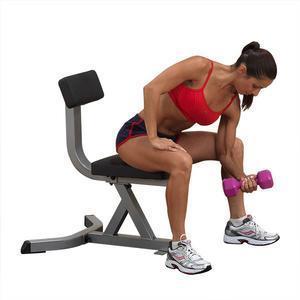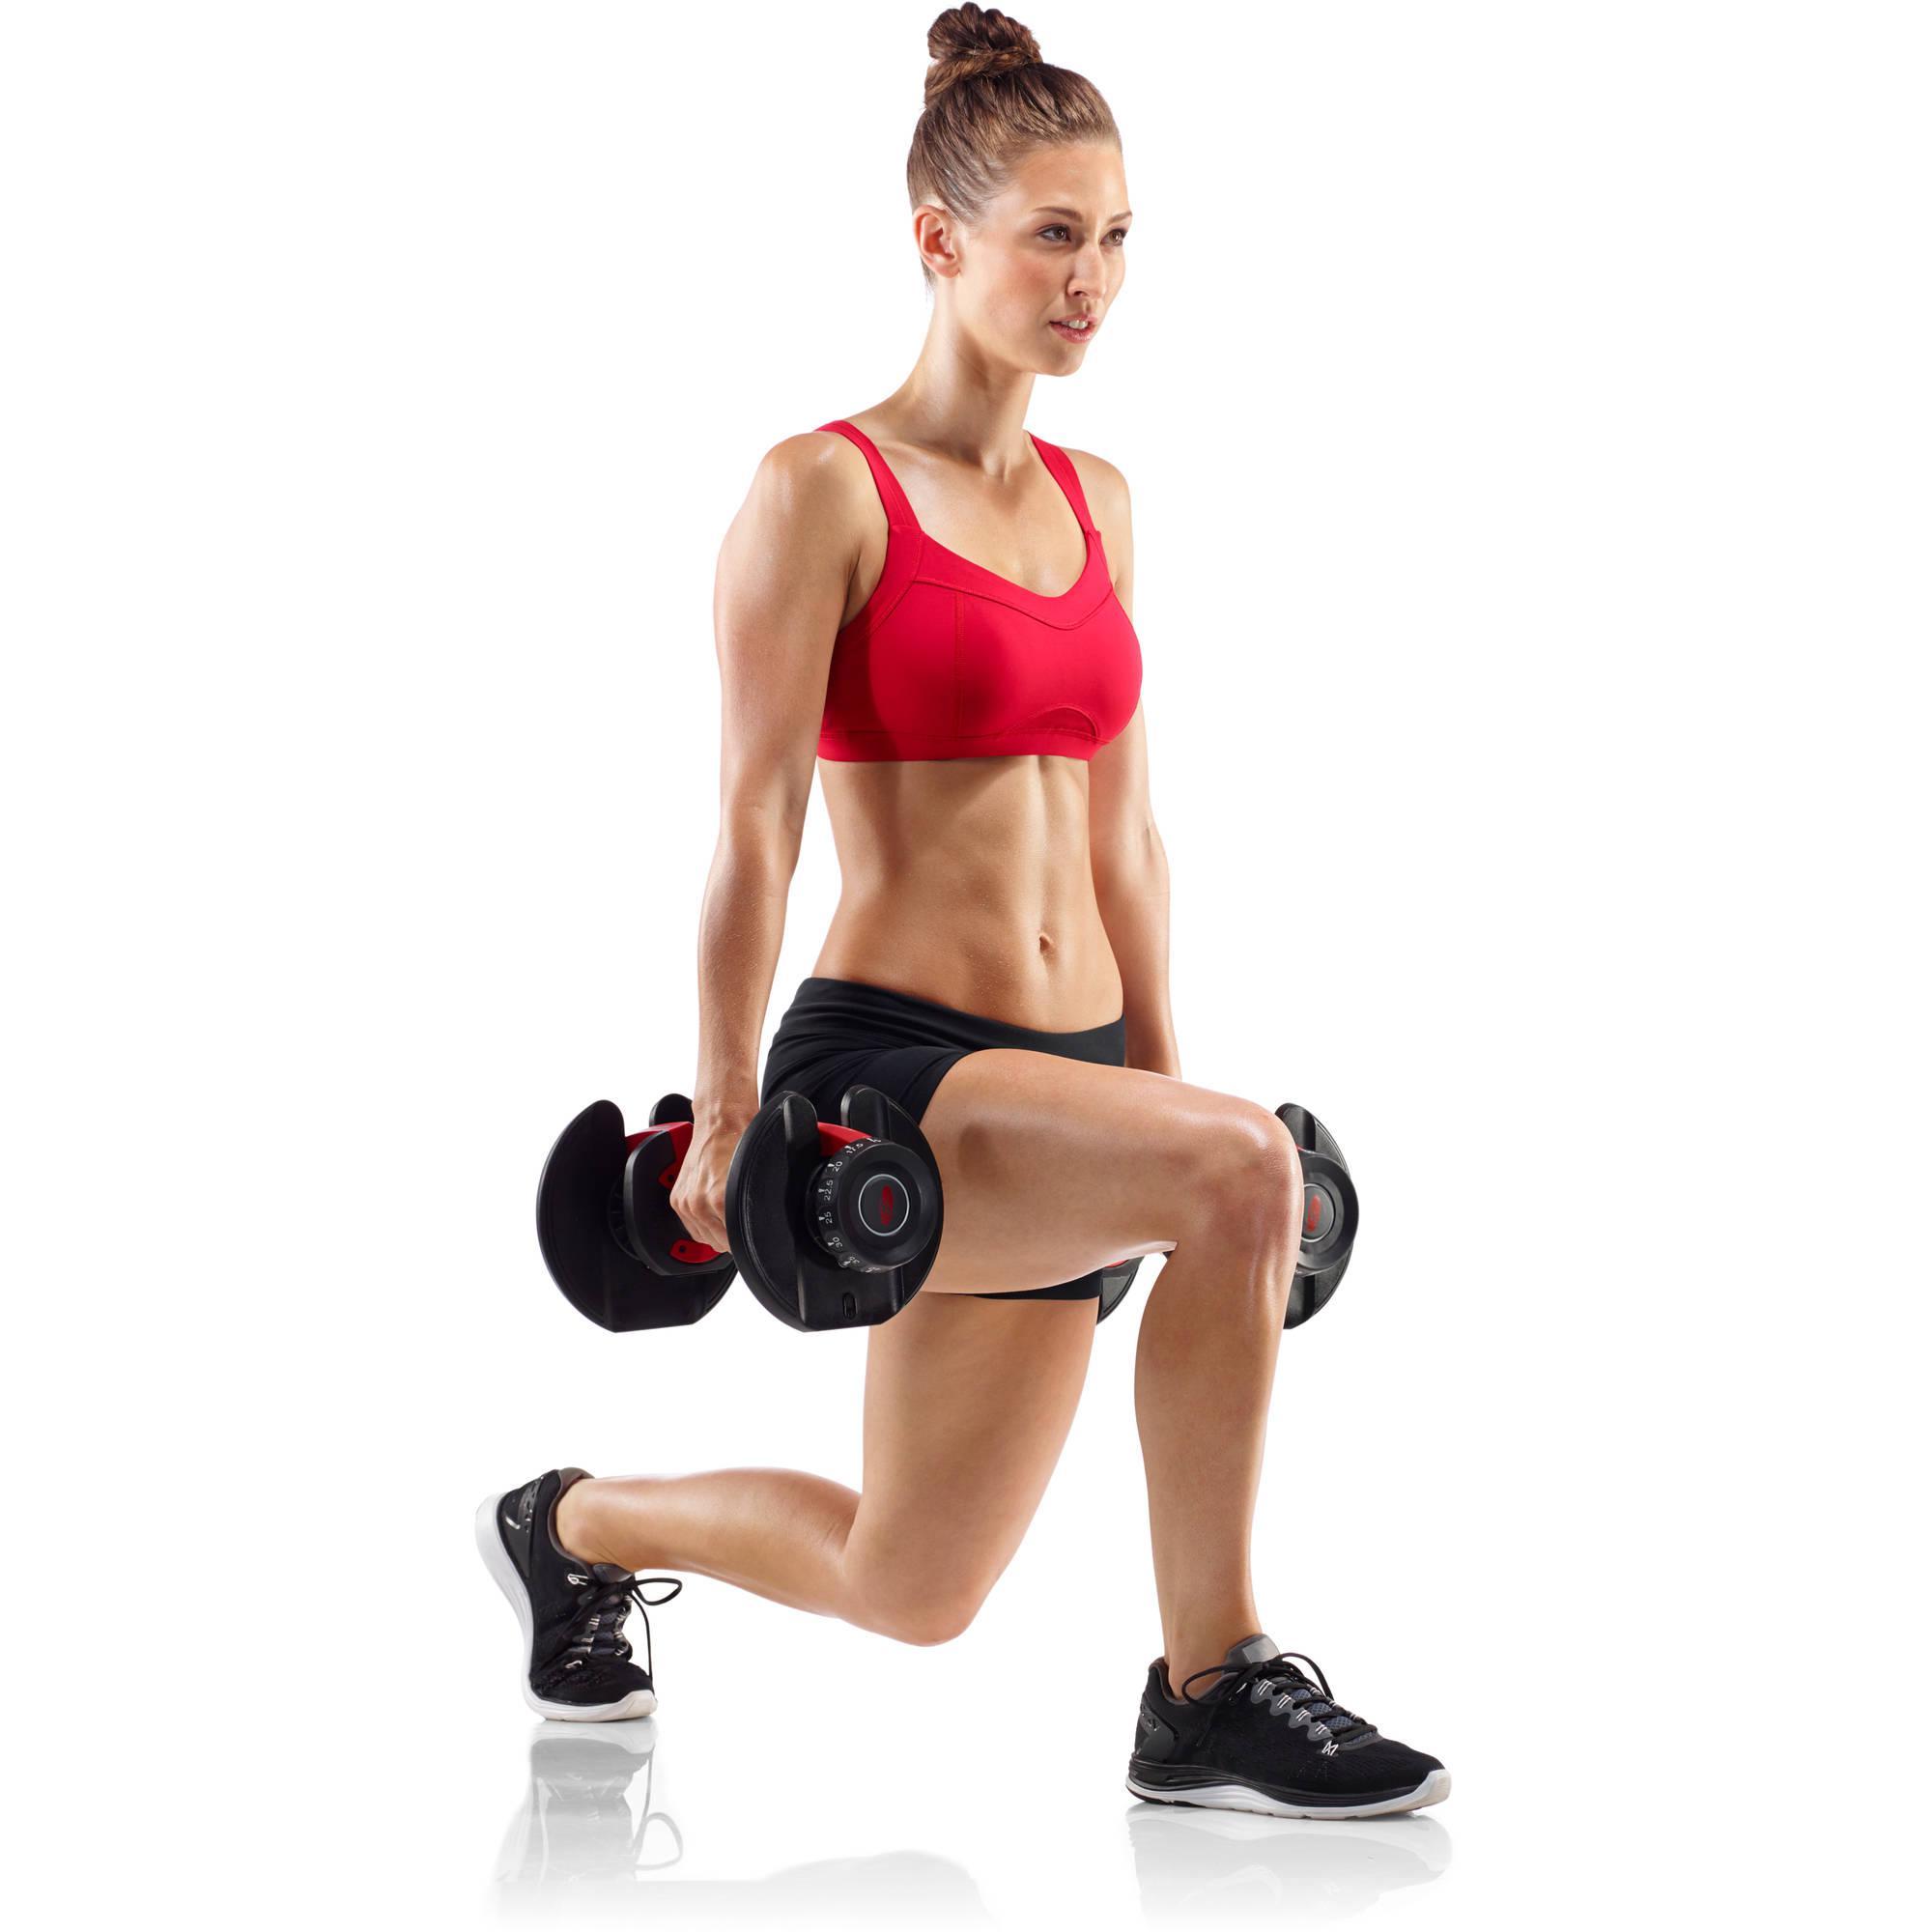The first image is the image on the left, the second image is the image on the right. Given the left and right images, does the statement "In the right image a woman is standing but kneeling towards the ground with one knee close to the floor." hold true? Answer yes or no. Yes. 